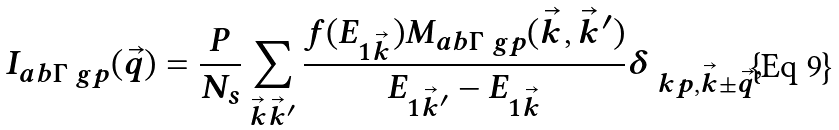Convert formula to latex. <formula><loc_0><loc_0><loc_500><loc_500>I _ { a b \Gamma \ g p } ( \vec { q } ) = \frac { P } { N _ { s } } \sum _ { \vec { k } \vec { k } ^ { \prime } } \frac { f ( E _ { 1 \vec { k } } ) M _ { a b \Gamma \ g p } ( \vec { k } , \vec { k } ^ { \prime } ) } { E _ { 1 \vec { k } ^ { \prime } } - E _ { 1 \vec { k } } } \delta _ { \ k p , \vec { k } \pm \vec { q } } ,</formula> 